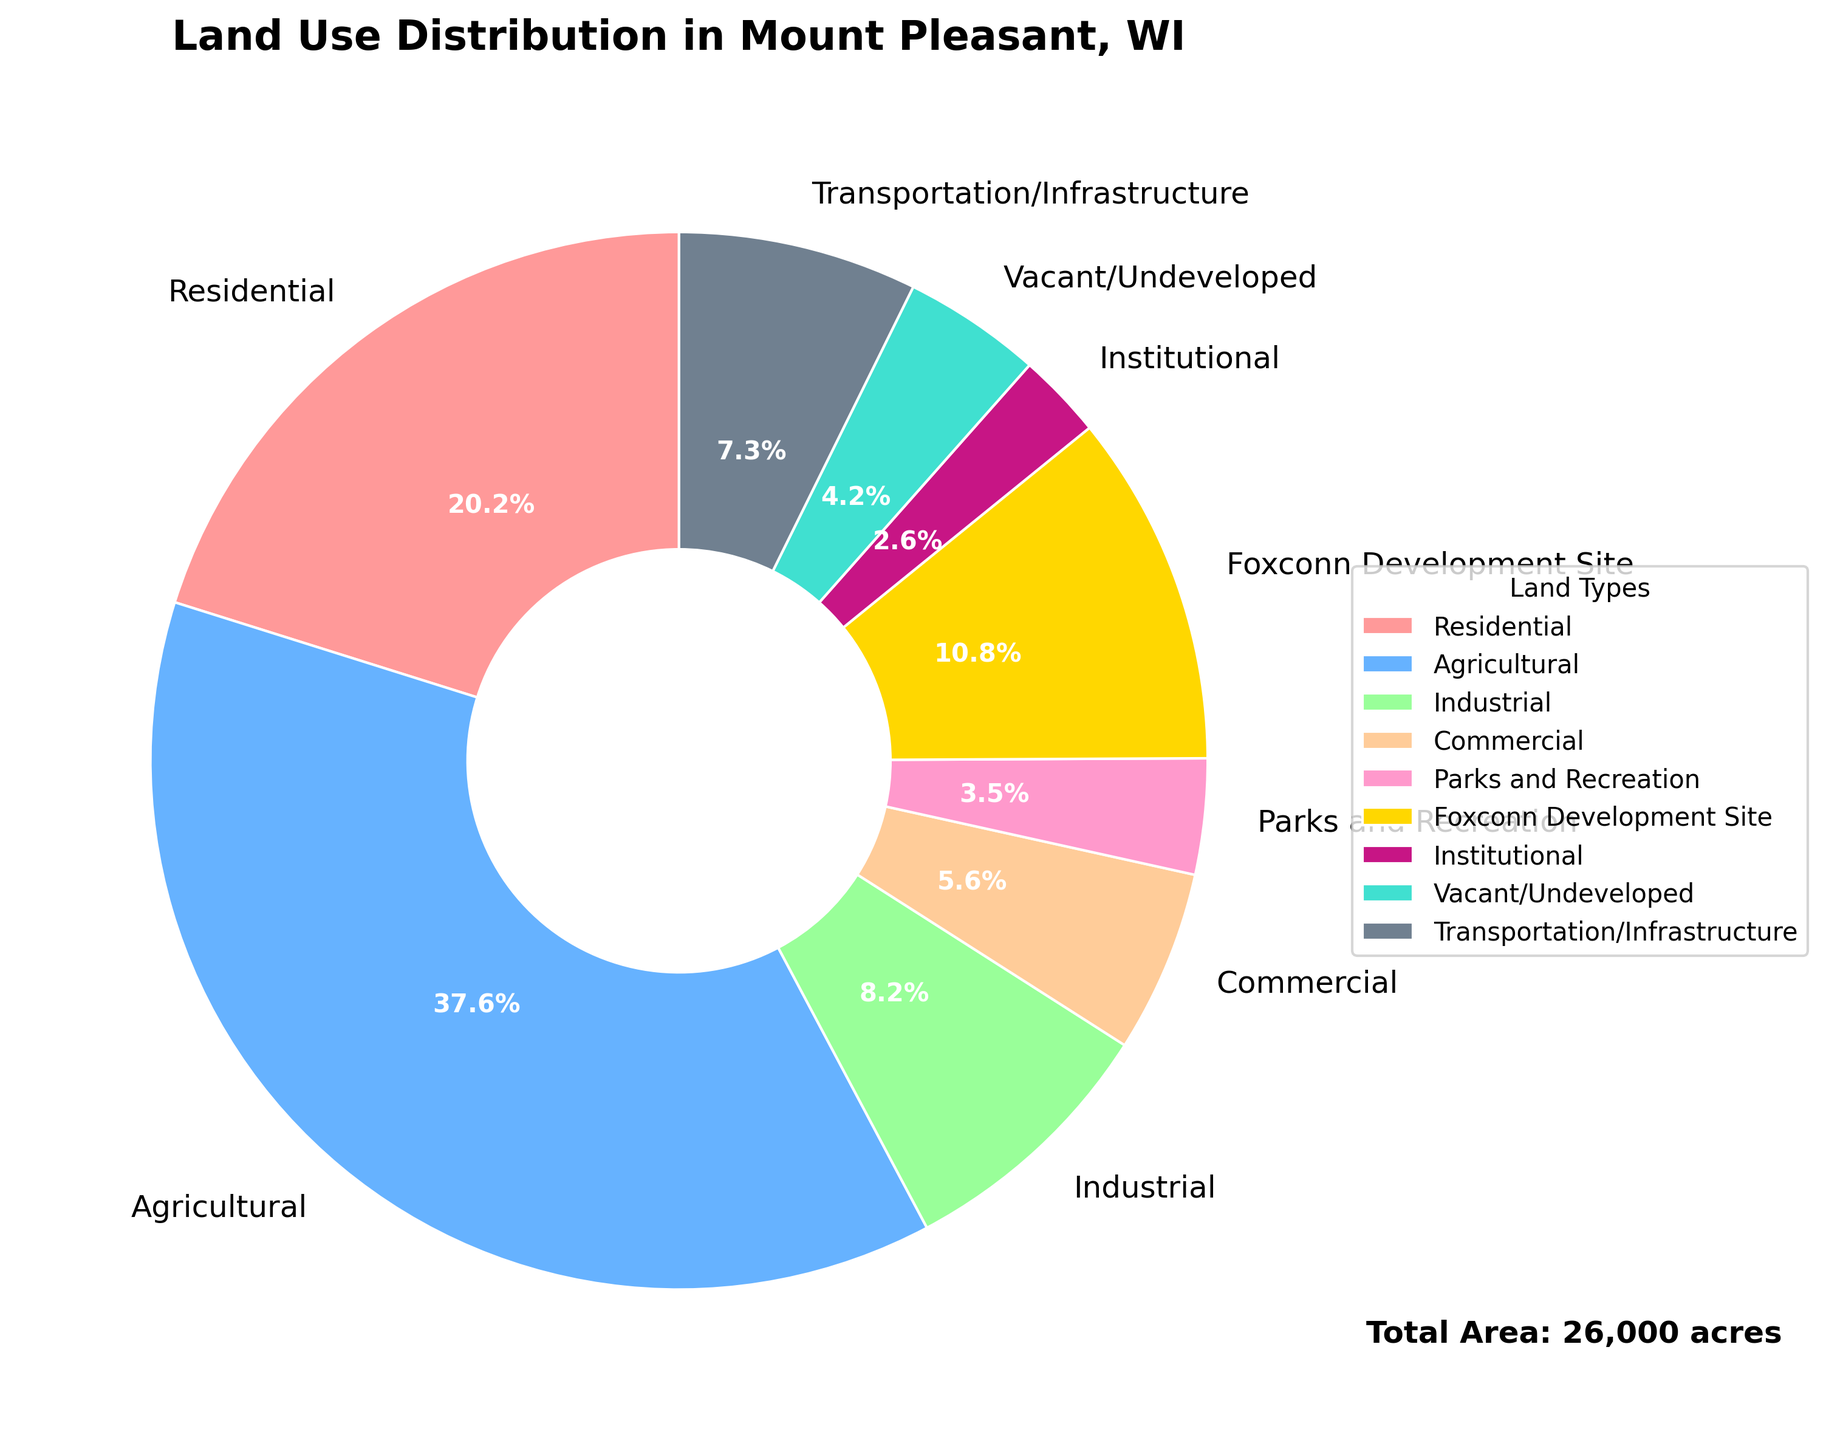Which land type occupies the largest area? By observing the pie chart, the agricultural segment occupies the largest fraction. The legend confirms this with 9780 acres marked for agricultural use.
Answer: Agricultural What percentage of the total area is residential? The pie chart provides the percentage for each segment. The residential area is marked as contributing 5240 acres. Summing all areas gives a total of 26000 acres. Therefore, the percentage is (5240/26000) * 100 = 20.2% as shown in the chart.
Answer: 20.2% How does the area of the Foxconn Development Site compare to the area of commercial land? By looking at the pie chart, Foxconn Development Site occupies 2800 acres whereas commercial land occupies 1450 acres. Foxconn Development is larger.
Answer: Foxconn Development is larger What is the combined area of Parks and Recreation and Vacant/Undeveloped land? By adding the areas from the chart, Parks and Recreation covers 920 acres and Vacant/Undeveloped land covers 1100 acres. Combined area: 920 + 1100 = 2020 acres.
Answer: 2020 acres Which land type has the smallest percentage of the total area? By observing the chart, Institutional occupies the smallest fraction in both area (680 acres) and visual representation as seen on the pie chart.
Answer: Institutional If the residential area were to be increased by 10%, what would be the new area? Current residential area is 5240 acres. Increasing by 10% means adding 524 acres (10% of 5240). New area: 5240 + 524 = 5764 acres.
Answer: 5764 acres How does the area dedicated to transportation/infrastructure compare with that dedicated to industrial use? From the pie chart, transportation/infrastructure area is 1900 acres while industrial is 2130 acres. Industrial area is larger.
Answer: Industrial is larger What is the total area covered by commercial, transportation/infrastructure, and institutional land types? Adding the areas from the chart: commercial (1450 acres), transportation/infrastructure (1900 acres), and institutional (680 acres). Combined area: 1450 + 1900 + 680 = 4030 acres.
Answer: 4030 acres Which land type has a similar area to the Foxconn Development Site? By comparing the areas, agricultural land (9780 acres) is much larger while residential (5240 acres), commercial (1450 acres), and others are smaller. None are very close, but the Parks and Recreation (920 acres) are the most visually comparable though still quite different.
Answer: Parks and Recreation is closest 